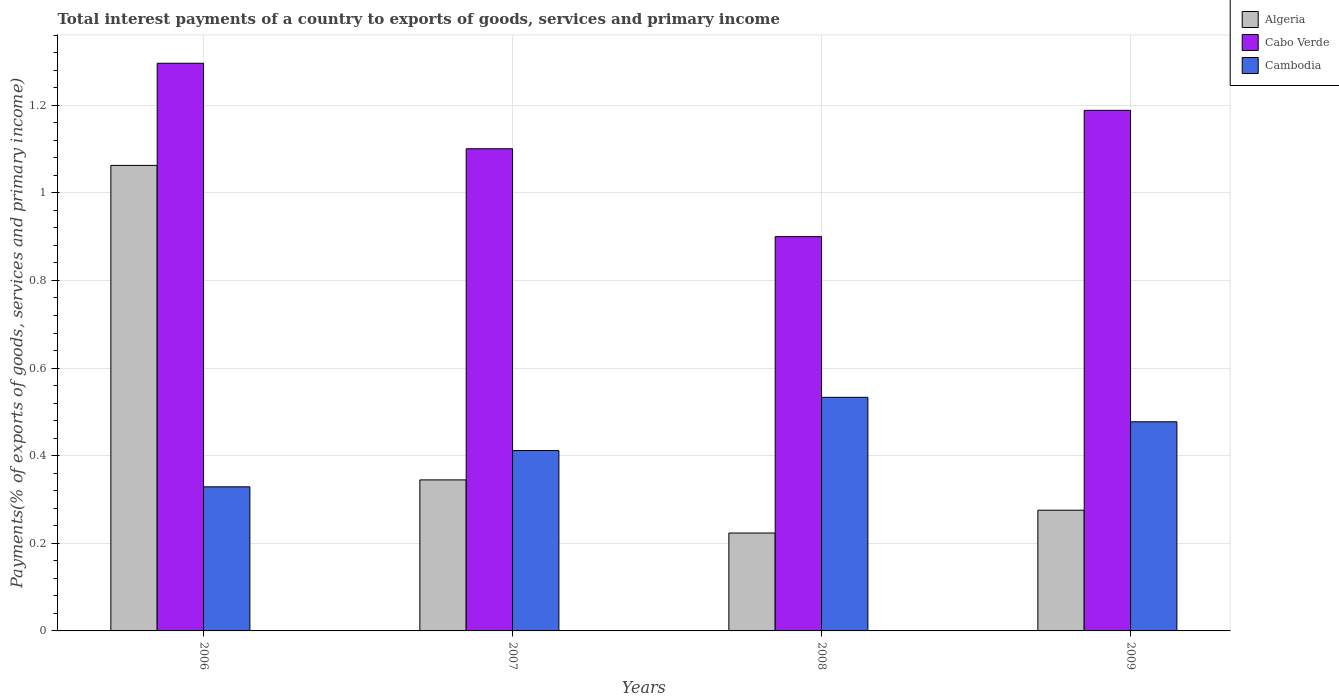How many groups of bars are there?
Ensure brevity in your answer.  4. Are the number of bars on each tick of the X-axis equal?
Offer a terse response. Yes. How many bars are there on the 2nd tick from the left?
Offer a terse response. 3. What is the label of the 2nd group of bars from the left?
Your answer should be very brief. 2007. In how many cases, is the number of bars for a given year not equal to the number of legend labels?
Provide a short and direct response. 0. What is the total interest payments in Algeria in 2006?
Your response must be concise. 1.06. Across all years, what is the maximum total interest payments in Cambodia?
Offer a terse response. 0.53. Across all years, what is the minimum total interest payments in Algeria?
Make the answer very short. 0.22. In which year was the total interest payments in Algeria maximum?
Offer a terse response. 2006. In which year was the total interest payments in Cabo Verde minimum?
Provide a short and direct response. 2008. What is the total total interest payments in Algeria in the graph?
Your answer should be compact. 1.91. What is the difference between the total interest payments in Cabo Verde in 2006 and that in 2007?
Offer a terse response. 0.2. What is the difference between the total interest payments in Cambodia in 2007 and the total interest payments in Algeria in 2009?
Your answer should be compact. 0.14. What is the average total interest payments in Cabo Verde per year?
Offer a terse response. 1.12. In the year 2006, what is the difference between the total interest payments in Algeria and total interest payments in Cambodia?
Your response must be concise. 0.73. What is the ratio of the total interest payments in Cabo Verde in 2007 to that in 2008?
Give a very brief answer. 1.22. Is the total interest payments in Algeria in 2006 less than that in 2007?
Keep it short and to the point. No. Is the difference between the total interest payments in Algeria in 2007 and 2009 greater than the difference between the total interest payments in Cambodia in 2007 and 2009?
Offer a terse response. Yes. What is the difference between the highest and the second highest total interest payments in Cabo Verde?
Provide a short and direct response. 0.11. What is the difference between the highest and the lowest total interest payments in Algeria?
Ensure brevity in your answer.  0.84. In how many years, is the total interest payments in Cabo Verde greater than the average total interest payments in Cabo Verde taken over all years?
Provide a short and direct response. 2. Is the sum of the total interest payments in Algeria in 2006 and 2008 greater than the maximum total interest payments in Cambodia across all years?
Keep it short and to the point. Yes. What does the 2nd bar from the left in 2006 represents?
Offer a terse response. Cabo Verde. What does the 1st bar from the right in 2007 represents?
Provide a succinct answer. Cambodia. How many bars are there?
Offer a very short reply. 12. Are all the bars in the graph horizontal?
Your response must be concise. No. Does the graph contain any zero values?
Make the answer very short. No. What is the title of the graph?
Provide a succinct answer. Total interest payments of a country to exports of goods, services and primary income. What is the label or title of the X-axis?
Make the answer very short. Years. What is the label or title of the Y-axis?
Your answer should be very brief. Payments(% of exports of goods, services and primary income). What is the Payments(% of exports of goods, services and primary income) in Algeria in 2006?
Your answer should be very brief. 1.06. What is the Payments(% of exports of goods, services and primary income) of Cabo Verde in 2006?
Provide a succinct answer. 1.3. What is the Payments(% of exports of goods, services and primary income) in Cambodia in 2006?
Make the answer very short. 0.33. What is the Payments(% of exports of goods, services and primary income) of Algeria in 2007?
Offer a very short reply. 0.34. What is the Payments(% of exports of goods, services and primary income) in Cabo Verde in 2007?
Offer a very short reply. 1.1. What is the Payments(% of exports of goods, services and primary income) in Cambodia in 2007?
Provide a succinct answer. 0.41. What is the Payments(% of exports of goods, services and primary income) of Algeria in 2008?
Keep it short and to the point. 0.22. What is the Payments(% of exports of goods, services and primary income) of Cabo Verde in 2008?
Make the answer very short. 0.9. What is the Payments(% of exports of goods, services and primary income) of Cambodia in 2008?
Give a very brief answer. 0.53. What is the Payments(% of exports of goods, services and primary income) of Algeria in 2009?
Offer a terse response. 0.28. What is the Payments(% of exports of goods, services and primary income) in Cabo Verde in 2009?
Give a very brief answer. 1.19. What is the Payments(% of exports of goods, services and primary income) in Cambodia in 2009?
Make the answer very short. 0.48. Across all years, what is the maximum Payments(% of exports of goods, services and primary income) of Algeria?
Your answer should be very brief. 1.06. Across all years, what is the maximum Payments(% of exports of goods, services and primary income) in Cabo Verde?
Give a very brief answer. 1.3. Across all years, what is the maximum Payments(% of exports of goods, services and primary income) of Cambodia?
Make the answer very short. 0.53. Across all years, what is the minimum Payments(% of exports of goods, services and primary income) in Algeria?
Provide a short and direct response. 0.22. Across all years, what is the minimum Payments(% of exports of goods, services and primary income) of Cabo Verde?
Your answer should be very brief. 0.9. Across all years, what is the minimum Payments(% of exports of goods, services and primary income) of Cambodia?
Keep it short and to the point. 0.33. What is the total Payments(% of exports of goods, services and primary income) of Algeria in the graph?
Provide a short and direct response. 1.91. What is the total Payments(% of exports of goods, services and primary income) of Cabo Verde in the graph?
Offer a terse response. 4.48. What is the total Payments(% of exports of goods, services and primary income) in Cambodia in the graph?
Offer a very short reply. 1.75. What is the difference between the Payments(% of exports of goods, services and primary income) in Algeria in 2006 and that in 2007?
Keep it short and to the point. 0.72. What is the difference between the Payments(% of exports of goods, services and primary income) in Cabo Verde in 2006 and that in 2007?
Ensure brevity in your answer.  0.2. What is the difference between the Payments(% of exports of goods, services and primary income) of Cambodia in 2006 and that in 2007?
Make the answer very short. -0.08. What is the difference between the Payments(% of exports of goods, services and primary income) of Algeria in 2006 and that in 2008?
Provide a short and direct response. 0.84. What is the difference between the Payments(% of exports of goods, services and primary income) in Cabo Verde in 2006 and that in 2008?
Make the answer very short. 0.4. What is the difference between the Payments(% of exports of goods, services and primary income) in Cambodia in 2006 and that in 2008?
Provide a short and direct response. -0.2. What is the difference between the Payments(% of exports of goods, services and primary income) in Algeria in 2006 and that in 2009?
Offer a terse response. 0.79. What is the difference between the Payments(% of exports of goods, services and primary income) of Cabo Verde in 2006 and that in 2009?
Offer a very short reply. 0.11. What is the difference between the Payments(% of exports of goods, services and primary income) of Cambodia in 2006 and that in 2009?
Make the answer very short. -0.15. What is the difference between the Payments(% of exports of goods, services and primary income) of Algeria in 2007 and that in 2008?
Provide a short and direct response. 0.12. What is the difference between the Payments(% of exports of goods, services and primary income) in Cabo Verde in 2007 and that in 2008?
Your answer should be compact. 0.2. What is the difference between the Payments(% of exports of goods, services and primary income) of Cambodia in 2007 and that in 2008?
Offer a very short reply. -0.12. What is the difference between the Payments(% of exports of goods, services and primary income) in Algeria in 2007 and that in 2009?
Offer a very short reply. 0.07. What is the difference between the Payments(% of exports of goods, services and primary income) in Cabo Verde in 2007 and that in 2009?
Give a very brief answer. -0.09. What is the difference between the Payments(% of exports of goods, services and primary income) of Cambodia in 2007 and that in 2009?
Keep it short and to the point. -0.07. What is the difference between the Payments(% of exports of goods, services and primary income) of Algeria in 2008 and that in 2009?
Offer a very short reply. -0.05. What is the difference between the Payments(% of exports of goods, services and primary income) in Cabo Verde in 2008 and that in 2009?
Give a very brief answer. -0.29. What is the difference between the Payments(% of exports of goods, services and primary income) of Cambodia in 2008 and that in 2009?
Provide a short and direct response. 0.06. What is the difference between the Payments(% of exports of goods, services and primary income) of Algeria in 2006 and the Payments(% of exports of goods, services and primary income) of Cabo Verde in 2007?
Give a very brief answer. -0.04. What is the difference between the Payments(% of exports of goods, services and primary income) of Algeria in 2006 and the Payments(% of exports of goods, services and primary income) of Cambodia in 2007?
Give a very brief answer. 0.65. What is the difference between the Payments(% of exports of goods, services and primary income) of Cabo Verde in 2006 and the Payments(% of exports of goods, services and primary income) of Cambodia in 2007?
Provide a succinct answer. 0.88. What is the difference between the Payments(% of exports of goods, services and primary income) in Algeria in 2006 and the Payments(% of exports of goods, services and primary income) in Cabo Verde in 2008?
Your answer should be very brief. 0.16. What is the difference between the Payments(% of exports of goods, services and primary income) in Algeria in 2006 and the Payments(% of exports of goods, services and primary income) in Cambodia in 2008?
Your response must be concise. 0.53. What is the difference between the Payments(% of exports of goods, services and primary income) of Cabo Verde in 2006 and the Payments(% of exports of goods, services and primary income) of Cambodia in 2008?
Provide a short and direct response. 0.76. What is the difference between the Payments(% of exports of goods, services and primary income) of Algeria in 2006 and the Payments(% of exports of goods, services and primary income) of Cabo Verde in 2009?
Your answer should be very brief. -0.13. What is the difference between the Payments(% of exports of goods, services and primary income) of Algeria in 2006 and the Payments(% of exports of goods, services and primary income) of Cambodia in 2009?
Provide a short and direct response. 0.59. What is the difference between the Payments(% of exports of goods, services and primary income) of Cabo Verde in 2006 and the Payments(% of exports of goods, services and primary income) of Cambodia in 2009?
Ensure brevity in your answer.  0.82. What is the difference between the Payments(% of exports of goods, services and primary income) of Algeria in 2007 and the Payments(% of exports of goods, services and primary income) of Cabo Verde in 2008?
Offer a very short reply. -0.56. What is the difference between the Payments(% of exports of goods, services and primary income) of Algeria in 2007 and the Payments(% of exports of goods, services and primary income) of Cambodia in 2008?
Ensure brevity in your answer.  -0.19. What is the difference between the Payments(% of exports of goods, services and primary income) in Cabo Verde in 2007 and the Payments(% of exports of goods, services and primary income) in Cambodia in 2008?
Ensure brevity in your answer.  0.57. What is the difference between the Payments(% of exports of goods, services and primary income) in Algeria in 2007 and the Payments(% of exports of goods, services and primary income) in Cabo Verde in 2009?
Your response must be concise. -0.84. What is the difference between the Payments(% of exports of goods, services and primary income) in Algeria in 2007 and the Payments(% of exports of goods, services and primary income) in Cambodia in 2009?
Give a very brief answer. -0.13. What is the difference between the Payments(% of exports of goods, services and primary income) of Cabo Verde in 2007 and the Payments(% of exports of goods, services and primary income) of Cambodia in 2009?
Keep it short and to the point. 0.62. What is the difference between the Payments(% of exports of goods, services and primary income) in Algeria in 2008 and the Payments(% of exports of goods, services and primary income) in Cabo Verde in 2009?
Your answer should be very brief. -0.96. What is the difference between the Payments(% of exports of goods, services and primary income) in Algeria in 2008 and the Payments(% of exports of goods, services and primary income) in Cambodia in 2009?
Offer a very short reply. -0.25. What is the difference between the Payments(% of exports of goods, services and primary income) of Cabo Verde in 2008 and the Payments(% of exports of goods, services and primary income) of Cambodia in 2009?
Make the answer very short. 0.42. What is the average Payments(% of exports of goods, services and primary income) of Algeria per year?
Your answer should be very brief. 0.48. What is the average Payments(% of exports of goods, services and primary income) of Cabo Verde per year?
Offer a very short reply. 1.12. What is the average Payments(% of exports of goods, services and primary income) in Cambodia per year?
Provide a short and direct response. 0.44. In the year 2006, what is the difference between the Payments(% of exports of goods, services and primary income) of Algeria and Payments(% of exports of goods, services and primary income) of Cabo Verde?
Make the answer very short. -0.23. In the year 2006, what is the difference between the Payments(% of exports of goods, services and primary income) of Algeria and Payments(% of exports of goods, services and primary income) of Cambodia?
Provide a succinct answer. 0.73. In the year 2006, what is the difference between the Payments(% of exports of goods, services and primary income) in Cabo Verde and Payments(% of exports of goods, services and primary income) in Cambodia?
Provide a succinct answer. 0.97. In the year 2007, what is the difference between the Payments(% of exports of goods, services and primary income) of Algeria and Payments(% of exports of goods, services and primary income) of Cabo Verde?
Your answer should be compact. -0.76. In the year 2007, what is the difference between the Payments(% of exports of goods, services and primary income) of Algeria and Payments(% of exports of goods, services and primary income) of Cambodia?
Make the answer very short. -0.07. In the year 2007, what is the difference between the Payments(% of exports of goods, services and primary income) of Cabo Verde and Payments(% of exports of goods, services and primary income) of Cambodia?
Provide a short and direct response. 0.69. In the year 2008, what is the difference between the Payments(% of exports of goods, services and primary income) of Algeria and Payments(% of exports of goods, services and primary income) of Cabo Verde?
Keep it short and to the point. -0.68. In the year 2008, what is the difference between the Payments(% of exports of goods, services and primary income) of Algeria and Payments(% of exports of goods, services and primary income) of Cambodia?
Give a very brief answer. -0.31. In the year 2008, what is the difference between the Payments(% of exports of goods, services and primary income) in Cabo Verde and Payments(% of exports of goods, services and primary income) in Cambodia?
Give a very brief answer. 0.37. In the year 2009, what is the difference between the Payments(% of exports of goods, services and primary income) of Algeria and Payments(% of exports of goods, services and primary income) of Cabo Verde?
Your answer should be very brief. -0.91. In the year 2009, what is the difference between the Payments(% of exports of goods, services and primary income) in Algeria and Payments(% of exports of goods, services and primary income) in Cambodia?
Keep it short and to the point. -0.2. In the year 2009, what is the difference between the Payments(% of exports of goods, services and primary income) in Cabo Verde and Payments(% of exports of goods, services and primary income) in Cambodia?
Give a very brief answer. 0.71. What is the ratio of the Payments(% of exports of goods, services and primary income) of Algeria in 2006 to that in 2007?
Offer a very short reply. 3.08. What is the ratio of the Payments(% of exports of goods, services and primary income) in Cabo Verde in 2006 to that in 2007?
Ensure brevity in your answer.  1.18. What is the ratio of the Payments(% of exports of goods, services and primary income) of Cambodia in 2006 to that in 2007?
Keep it short and to the point. 0.8. What is the ratio of the Payments(% of exports of goods, services and primary income) in Algeria in 2006 to that in 2008?
Provide a short and direct response. 4.75. What is the ratio of the Payments(% of exports of goods, services and primary income) of Cabo Verde in 2006 to that in 2008?
Make the answer very short. 1.44. What is the ratio of the Payments(% of exports of goods, services and primary income) of Cambodia in 2006 to that in 2008?
Your answer should be very brief. 0.62. What is the ratio of the Payments(% of exports of goods, services and primary income) in Algeria in 2006 to that in 2009?
Offer a terse response. 3.86. What is the ratio of the Payments(% of exports of goods, services and primary income) in Cabo Verde in 2006 to that in 2009?
Make the answer very short. 1.09. What is the ratio of the Payments(% of exports of goods, services and primary income) of Cambodia in 2006 to that in 2009?
Make the answer very short. 0.69. What is the ratio of the Payments(% of exports of goods, services and primary income) in Algeria in 2007 to that in 2008?
Keep it short and to the point. 1.54. What is the ratio of the Payments(% of exports of goods, services and primary income) in Cabo Verde in 2007 to that in 2008?
Your answer should be compact. 1.22. What is the ratio of the Payments(% of exports of goods, services and primary income) of Cambodia in 2007 to that in 2008?
Keep it short and to the point. 0.77. What is the ratio of the Payments(% of exports of goods, services and primary income) of Algeria in 2007 to that in 2009?
Provide a short and direct response. 1.25. What is the ratio of the Payments(% of exports of goods, services and primary income) in Cabo Verde in 2007 to that in 2009?
Ensure brevity in your answer.  0.93. What is the ratio of the Payments(% of exports of goods, services and primary income) in Cambodia in 2007 to that in 2009?
Give a very brief answer. 0.86. What is the ratio of the Payments(% of exports of goods, services and primary income) in Algeria in 2008 to that in 2009?
Your response must be concise. 0.81. What is the ratio of the Payments(% of exports of goods, services and primary income) of Cabo Verde in 2008 to that in 2009?
Your answer should be very brief. 0.76. What is the ratio of the Payments(% of exports of goods, services and primary income) in Cambodia in 2008 to that in 2009?
Ensure brevity in your answer.  1.12. What is the difference between the highest and the second highest Payments(% of exports of goods, services and primary income) in Algeria?
Offer a terse response. 0.72. What is the difference between the highest and the second highest Payments(% of exports of goods, services and primary income) of Cabo Verde?
Give a very brief answer. 0.11. What is the difference between the highest and the second highest Payments(% of exports of goods, services and primary income) in Cambodia?
Provide a succinct answer. 0.06. What is the difference between the highest and the lowest Payments(% of exports of goods, services and primary income) of Algeria?
Provide a succinct answer. 0.84. What is the difference between the highest and the lowest Payments(% of exports of goods, services and primary income) of Cabo Verde?
Provide a short and direct response. 0.4. What is the difference between the highest and the lowest Payments(% of exports of goods, services and primary income) of Cambodia?
Give a very brief answer. 0.2. 